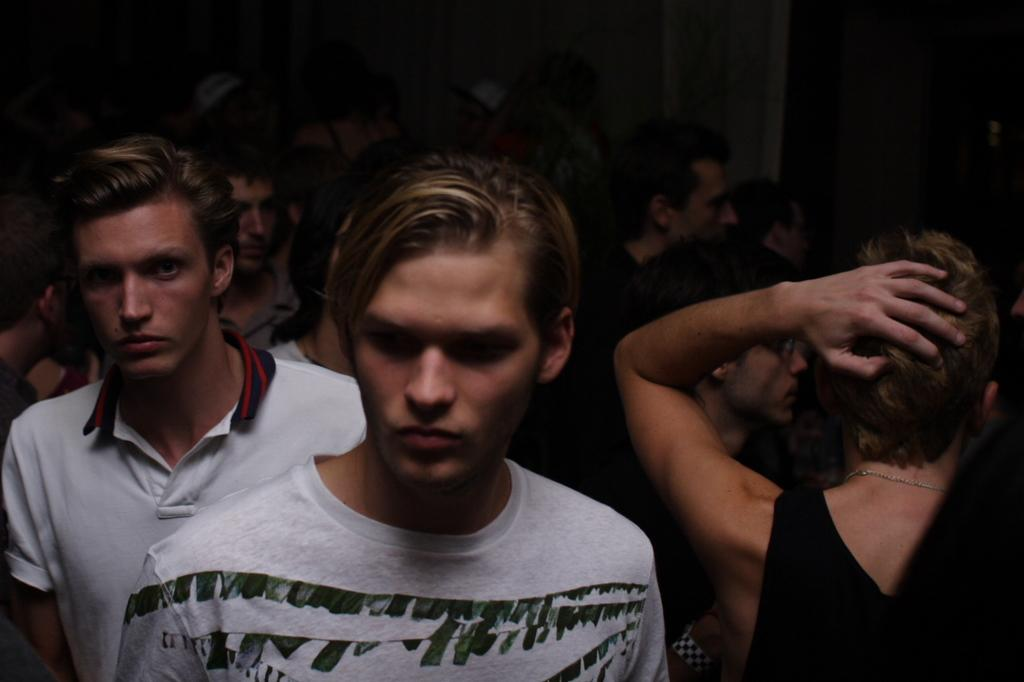Who or what is present in the image? There are people in the image. What can be seen in the background of the image? There is a wall in the background of the image. What type of fang is visible on the person in the image? There is no fang visible on any person in the image. What industry is represented by the people in the image? The image does not depict any specific industry; it simply shows people. 